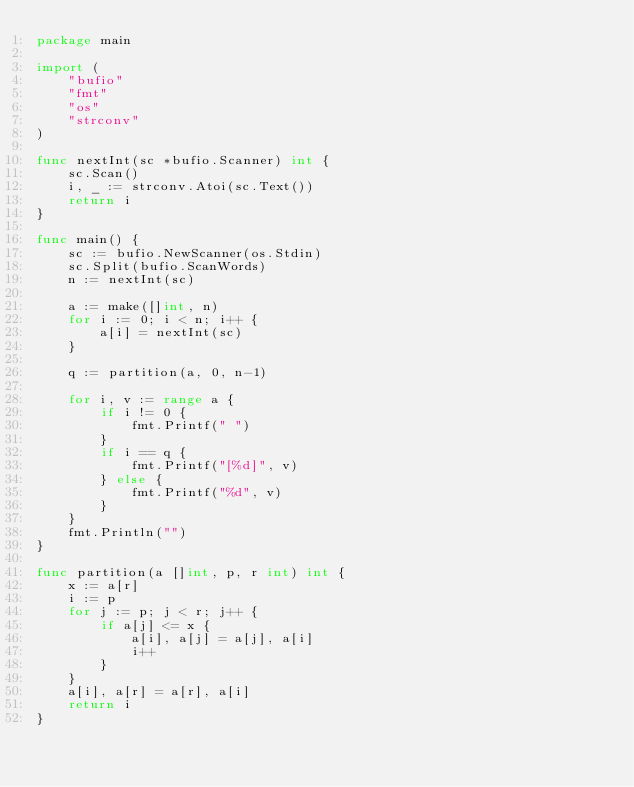Convert code to text. <code><loc_0><loc_0><loc_500><loc_500><_Go_>package main

import (
	"bufio"
	"fmt"
	"os"
	"strconv"
)

func nextInt(sc *bufio.Scanner) int {
	sc.Scan()
	i, _ := strconv.Atoi(sc.Text())
	return i
}

func main() {
	sc := bufio.NewScanner(os.Stdin)
	sc.Split(bufio.ScanWords)
	n := nextInt(sc)

	a := make([]int, n)
	for i := 0; i < n; i++ {
		a[i] = nextInt(sc)
	}

	q := partition(a, 0, n-1)

	for i, v := range a {
		if i != 0 {
			fmt.Printf(" ")
		}
		if i == q {
			fmt.Printf("[%d]", v)
		} else {
			fmt.Printf("%d", v)
		}
	}
	fmt.Println("")
}

func partition(a []int, p, r int) int {
	x := a[r]
	i := p
	for j := p; j < r; j++ {
		if a[j] <= x {
			a[i], a[j] = a[j], a[i]
			i++
		}
	}
	a[i], a[r] = a[r], a[i]
	return i
}</code> 